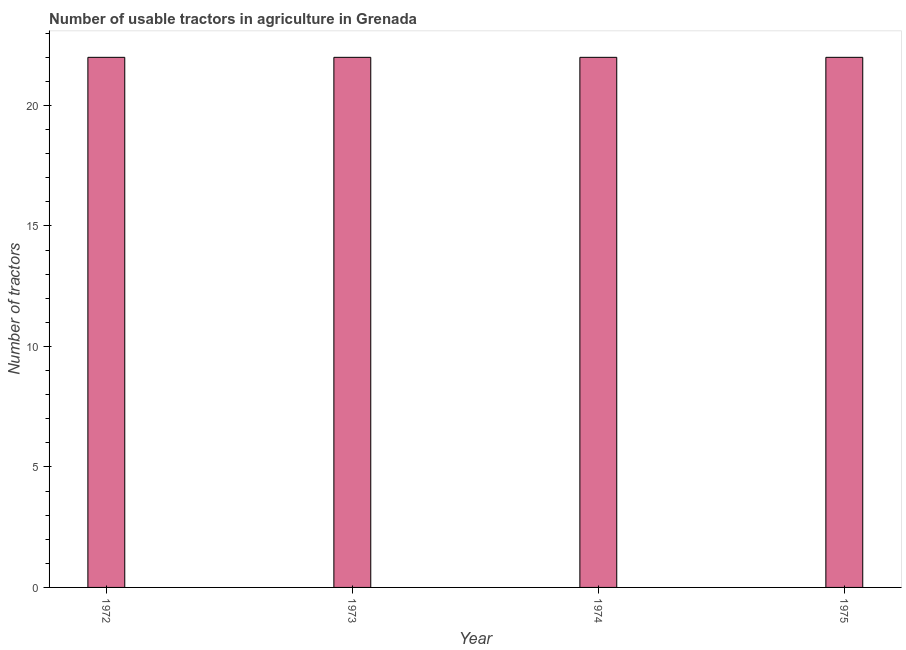Does the graph contain grids?
Offer a terse response. No. What is the title of the graph?
Keep it short and to the point. Number of usable tractors in agriculture in Grenada. What is the label or title of the Y-axis?
Offer a terse response. Number of tractors. What is the number of tractors in 1974?
Provide a short and direct response. 22. Across all years, what is the minimum number of tractors?
Your answer should be very brief. 22. In which year was the number of tractors maximum?
Your answer should be compact. 1972. In which year was the number of tractors minimum?
Provide a short and direct response. 1972. What is the difference between the number of tractors in 1972 and 1973?
Offer a very short reply. 0. What is the average number of tractors per year?
Give a very brief answer. 22. What is the median number of tractors?
Provide a succinct answer. 22. Do a majority of the years between 1973 and 1972 (inclusive) have number of tractors greater than 12 ?
Offer a very short reply. No. What is the ratio of the number of tractors in 1973 to that in 1974?
Give a very brief answer. 1. Is the difference between the number of tractors in 1973 and 1975 greater than the difference between any two years?
Your answer should be compact. Yes. Is the sum of the number of tractors in 1972 and 1975 greater than the maximum number of tractors across all years?
Make the answer very short. Yes. In how many years, is the number of tractors greater than the average number of tractors taken over all years?
Make the answer very short. 0. Are all the bars in the graph horizontal?
Offer a very short reply. No. How many years are there in the graph?
Your response must be concise. 4. Are the values on the major ticks of Y-axis written in scientific E-notation?
Offer a very short reply. No. What is the Number of tractors in 1972?
Provide a succinct answer. 22. What is the Number of tractors of 1973?
Make the answer very short. 22. What is the difference between the Number of tractors in 1972 and 1973?
Keep it short and to the point. 0. What is the difference between the Number of tractors in 1973 and 1975?
Your answer should be very brief. 0. What is the difference between the Number of tractors in 1974 and 1975?
Give a very brief answer. 0. What is the ratio of the Number of tractors in 1972 to that in 1973?
Ensure brevity in your answer.  1. What is the ratio of the Number of tractors in 1972 to that in 1974?
Your answer should be compact. 1. What is the ratio of the Number of tractors in 1973 to that in 1975?
Provide a succinct answer. 1. 